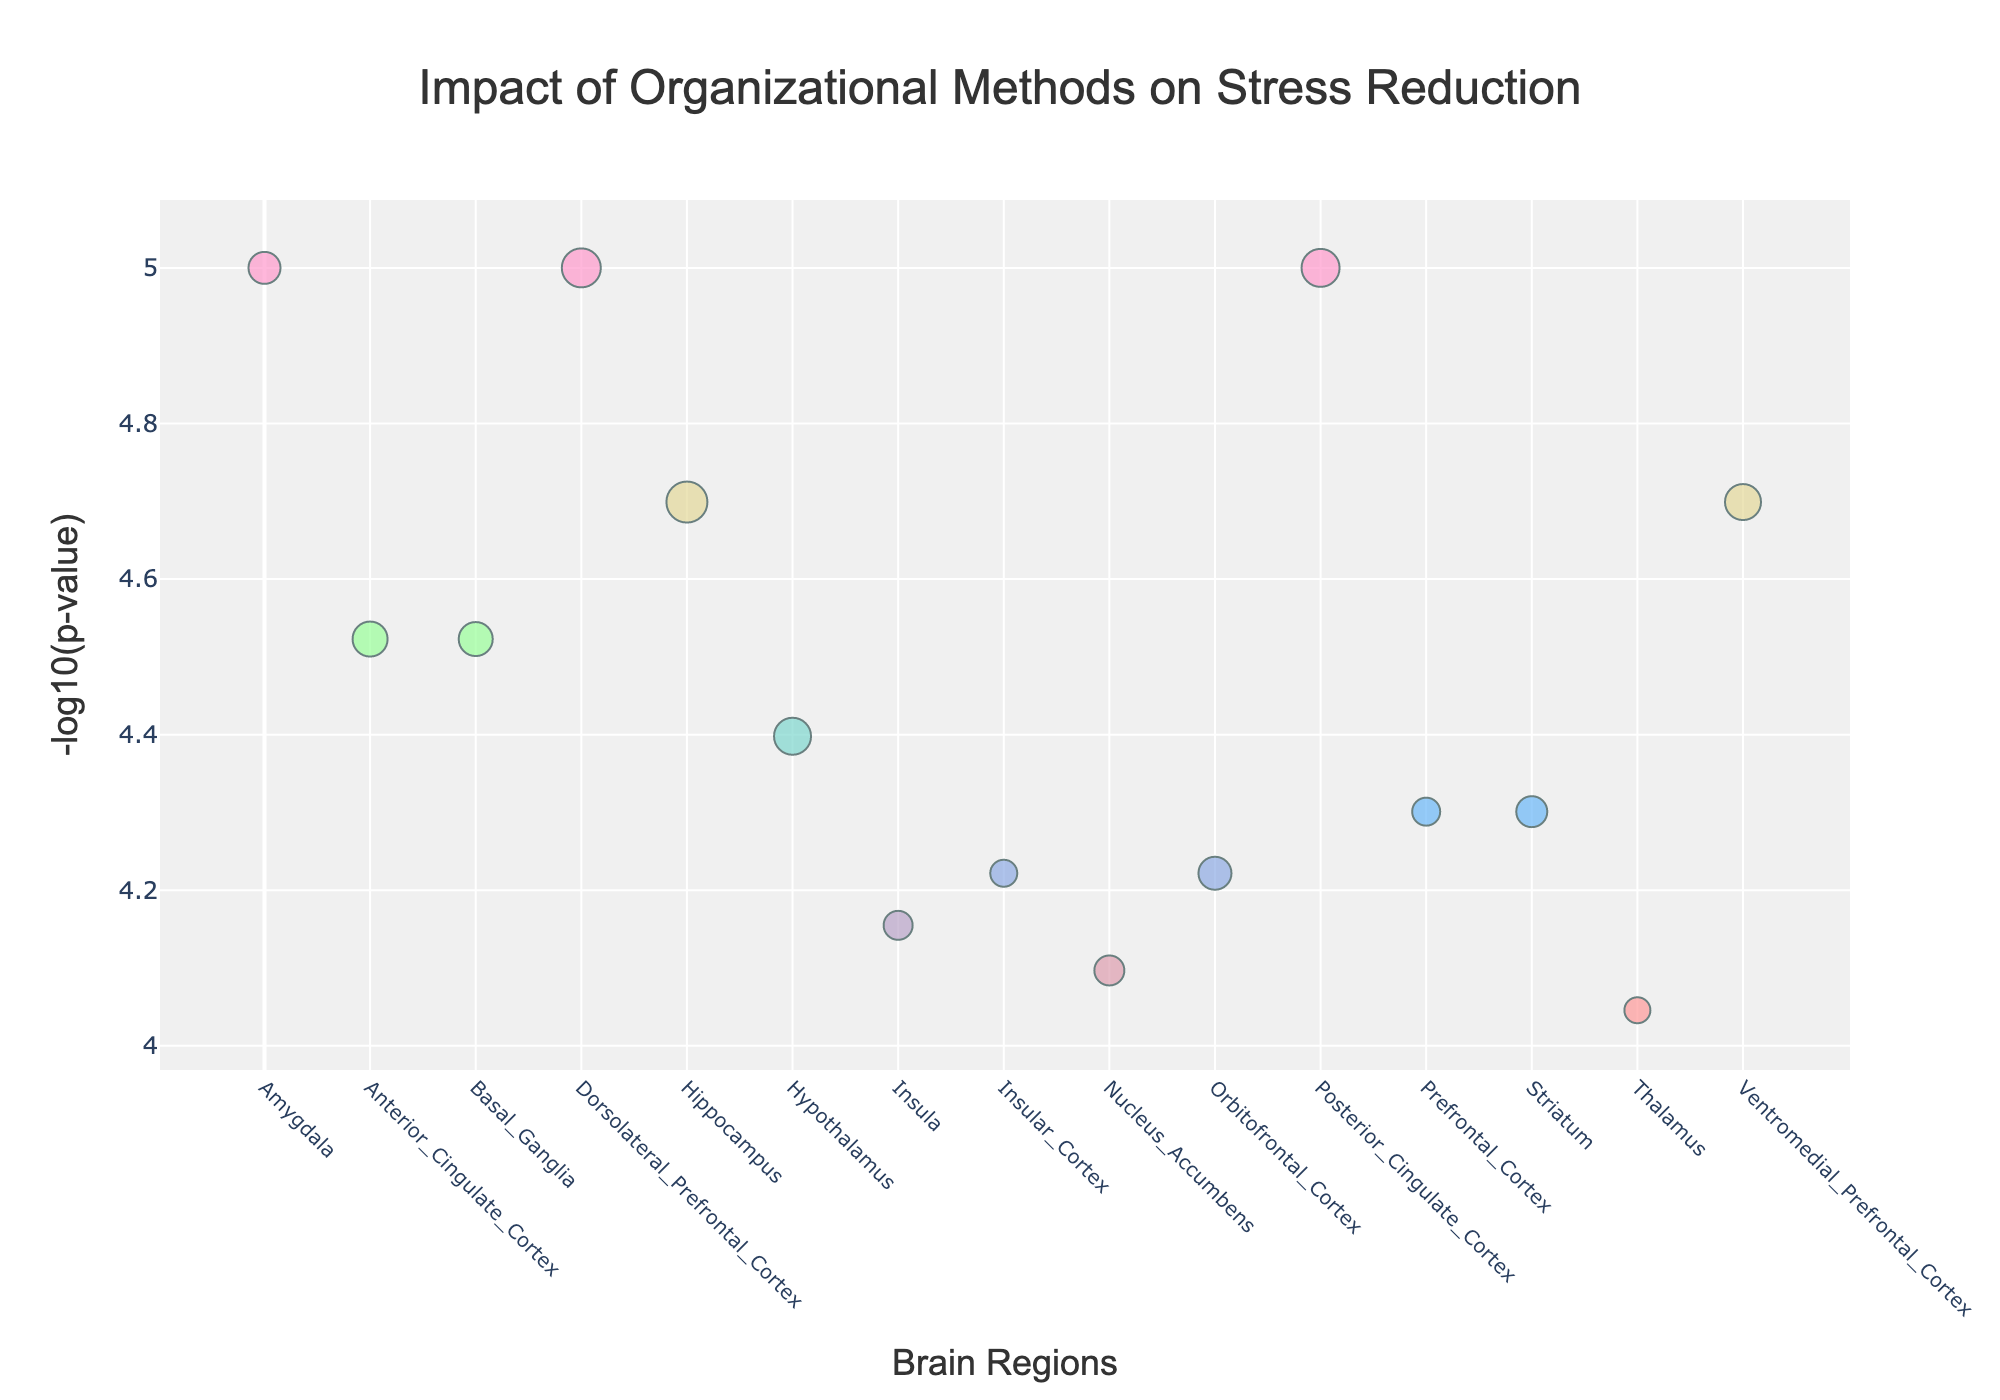How many different organizational methods are represented in the figure? By counting each unique data point (organizational method) represented in the plot, we determine the number of different methods shown.
Answer: 15 What is the title of the figure? The title is displayed at the top of the figure and summarizes the content presented.
Answer: Impact of Organizational Methods on Stress Reduction Which brain region corresponds to the point with the highest -log10(p-value)? By examining the vertical axis and identifying the highest point, we can check the corresponding x-axis value to find the brain region.
Answer: Amygdala (Konmari Folding) Which organizational method has the highest stress reduction score, and what is that score? Evaluate the data points to determine which marker is the largest in size since size represents the stress reduction score.
Answer: Minimalism, 4.1 What is the range of the -log10(p-value) axis? Observing the y-axis, the minimum and maximum values define the range of the -log10(p-value).
Answer: Approximately 4 to 5.4 How does the stress reduction score of Minimalism compare to Zone Cleaning? We compare the marker sizes of the two methods listed; Minimalism and Zone Cleaning.
Answer: Minimalism has a higher stress reduction score (4.1) compared to Zone Cleaning (3.7) Which organizational method targets the Prefrontal Cortex? By referring to the x-axis labels to match Prefrontal Cortex, and the corresponding marker an organizational method.
Answer: Color Coding For brain regions with a -log10(p-value) of about 5, which organizational methods are represented? Locate the points around -log10(p-value) of 5 and find their corresponding organizational methods.
Answer: Konmari Folding, Family Calendar System, Paperwork Filing System Which organizational method affects both Amygdala and Posterior Cingulate Cortex with significance? Evaluate brain regions by corresponding x-axis values close to the 5.0 -log10(p-value) line and check if any method appears twice.
Answer: No single method affects both, each method is unique per region What is the color scale used in the figure? By describing the colors used, ranging from light to dark shades.
Answer: Range from light pink to dark blue What is the stress reduction score for the organizational method impacting the Nucleus Accumbens? Check the marker size for the data point related to the Nucleus Accumbens.
Answer: 3.0 